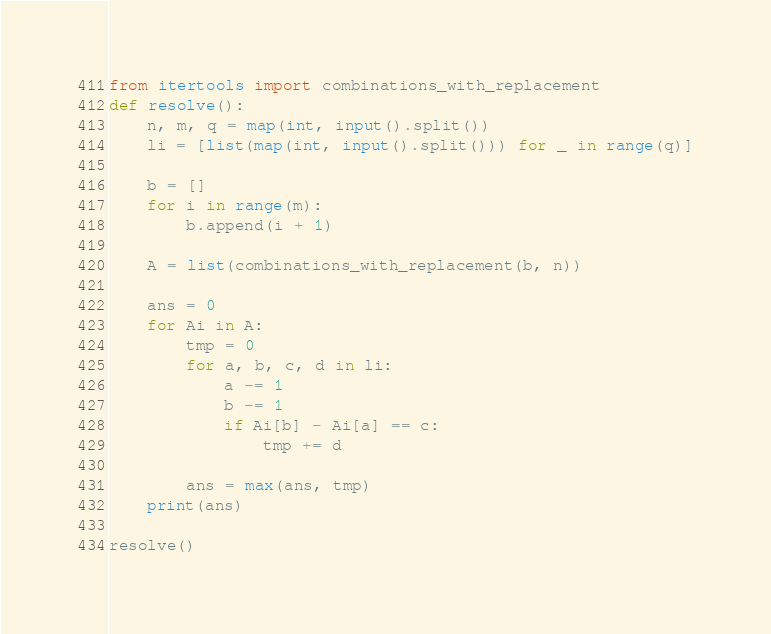<code> <loc_0><loc_0><loc_500><loc_500><_Python_>from itertools import combinations_with_replacement
def resolve():
    n, m, q = map(int, input().split())
    li = [list(map(int, input().split())) for _ in range(q)]

    b = []
    for i in range(m):
        b.append(i + 1)

    A = list(combinations_with_replacement(b, n))

    ans = 0
    for Ai in A:
        tmp = 0
        for a, b, c, d in li:
            a -= 1
            b -= 1
            if Ai[b] - Ai[a] == c:
                tmp += d

        ans = max(ans, tmp)
    print(ans)
    
resolve()</code> 